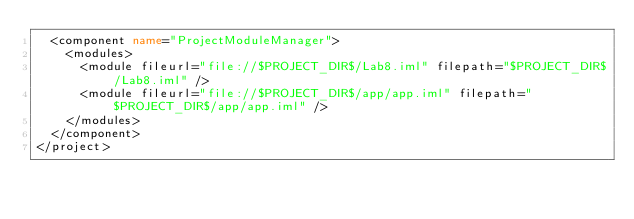<code> <loc_0><loc_0><loc_500><loc_500><_XML_>  <component name="ProjectModuleManager">
    <modules>
      <module fileurl="file://$PROJECT_DIR$/Lab8.iml" filepath="$PROJECT_DIR$/Lab8.iml" />
      <module fileurl="file://$PROJECT_DIR$/app/app.iml" filepath="$PROJECT_DIR$/app/app.iml" />
    </modules>
  </component>
</project></code> 